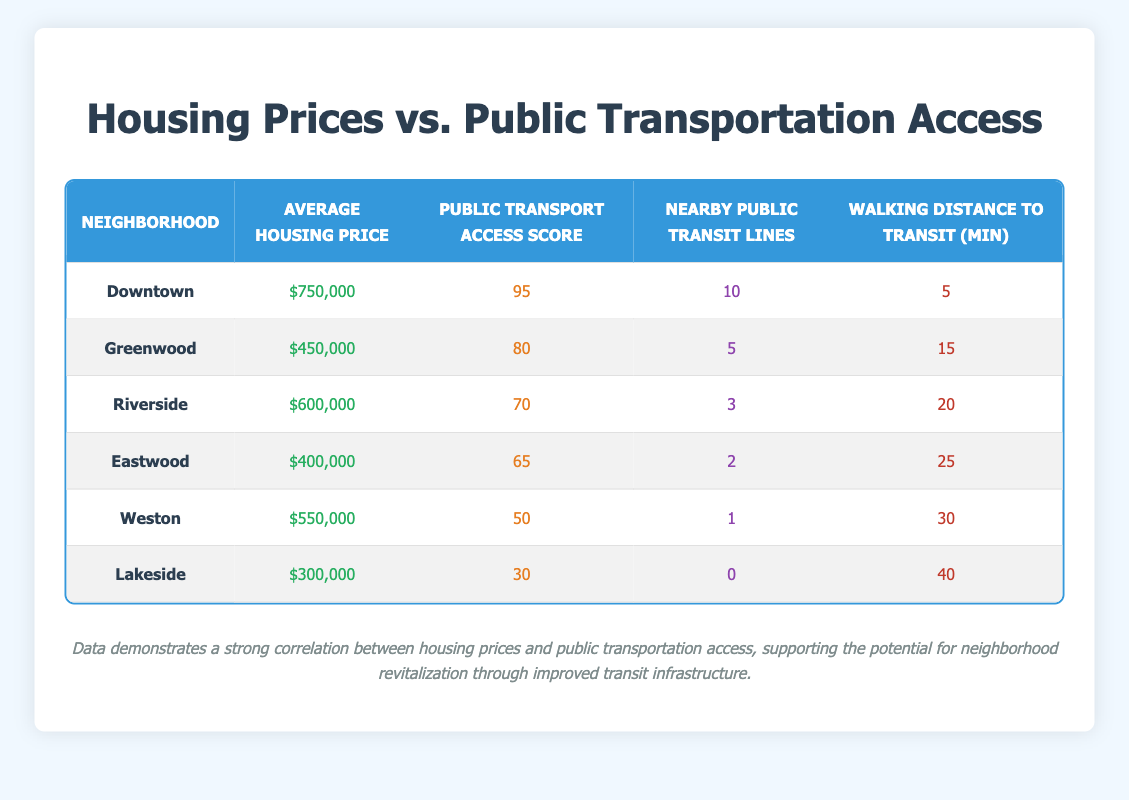What is the Average Housing Price in Downtown? The table indicates that the Average Housing Price for the Downtown neighborhood is listed as $750,000.
Answer: $750,000 What is the Public Transport Access Score for Lakeside? According to the table, Lakeside has a Public Transport Access Score of 30.
Answer: 30 Which neighborhood has the highest number of Nearby Public Transit Lines? The table shows that Downtown has the highest number of Nearby Public Transit Lines at 10.
Answer: Downtown Is the Average Housing Price in Greenwood greater than $400,000? Looking at the table, Greenwood has an Average Housing Price of $450,000, which is greater than $400,000.
Answer: Yes What is the combined Average Housing Price of Riverside and Weston? The Average Housing Price for Riverside is $600,000 and for Weston is $550,000. Adding these together gives $600,000 + $550,000 = $1,150,000.
Answer: $1,150,000 Are there any neighborhoods with a Public Transport Access Score below 50? By examining the table, the neighborhoods with a Public Transport Access Score below 50 are Weston (50) and Lakeside (30). Therefore, the answer is no.
Answer: No What is the Walking Distance to Transit for the neighborhood with an Average Housing Price of $400,000? For Eastwood, which has an Average Housing Price of $400,000, the Walking Distance to Transit is 25 minutes, as shown in the table.
Answer: 25 If we compare the Average Housing Prices of neighborhoods with a Public Transport Access Score above 70, what is their average? The neighborhoods with scores above 70 are Downtown (750000), Greenwood (450000), and Riverside (600000). Their total is $750,000 + $450,000 + $600,000 = $1,800,000. The average is $1,800,000 divided by 3, which equals $600,000.
Answer: $600,000 What can be inferred about the relationship between Walking Distance to Transit and Average Housing Price? Observing the table, as Walking Distance to Transit increases (from Downtown at 5 minutes to Lakeside at 40 minutes), the Average Housing Price typically decreases. For example, Downtown has the highest price and lowest walking distance. This suggests a negative correlation.
Answer: Negative correlation 